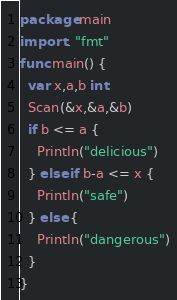Convert code to text. <code><loc_0><loc_0><loc_500><loc_500><_Go_>package main
import . "fmt"
func main() {
  var x,a,b int
  Scan(&x,&a,&b)
  if b <= a {
    Println("delicious")
  } else if b-a <= x {
    Println("safe")
  } else {
    Println("dangerous")
  }
}</code> 